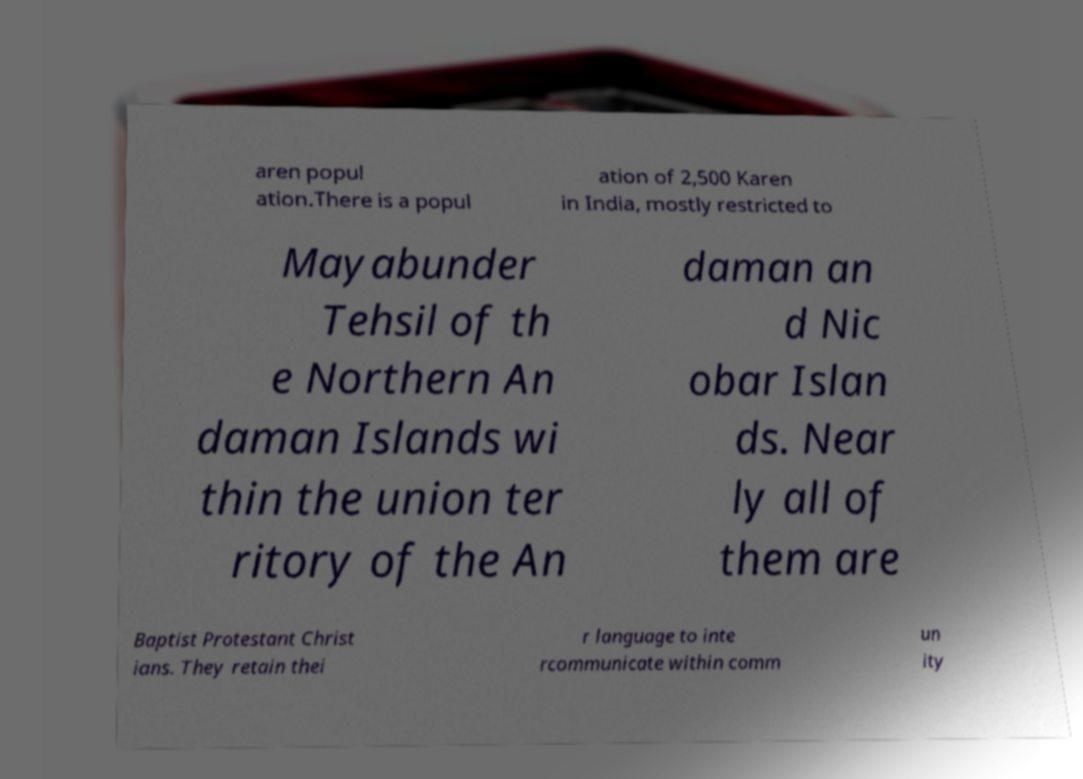Can you read and provide the text displayed in the image?This photo seems to have some interesting text. Can you extract and type it out for me? aren popul ation.There is a popul ation of 2,500 Karen in India, mostly restricted to Mayabunder Tehsil of th e Northern An daman Islands wi thin the union ter ritory of the An daman an d Nic obar Islan ds. Near ly all of them are Baptist Protestant Christ ians. They retain thei r language to inte rcommunicate within comm un ity 